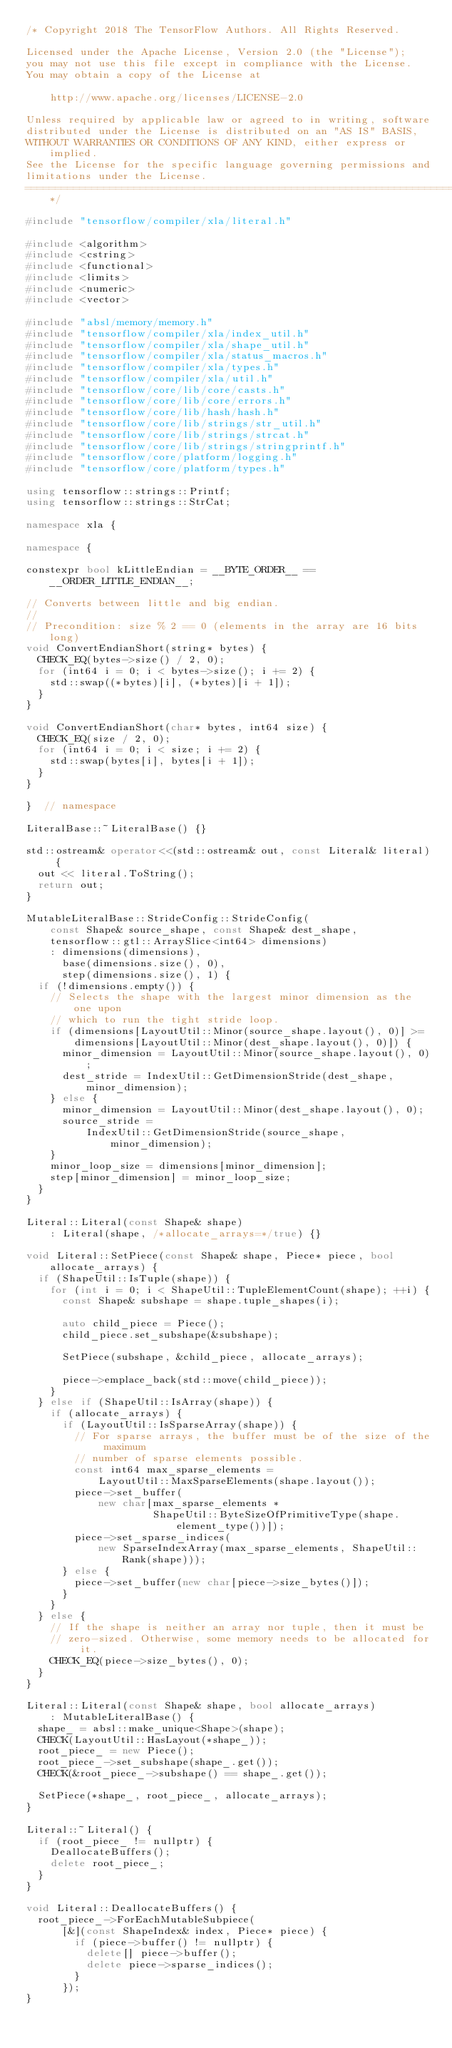<code> <loc_0><loc_0><loc_500><loc_500><_C++_>/* Copyright 2018 The TensorFlow Authors. All Rights Reserved.

Licensed under the Apache License, Version 2.0 (the "License");
you may not use this file except in compliance with the License.
You may obtain a copy of the License at

    http://www.apache.org/licenses/LICENSE-2.0

Unless required by applicable law or agreed to in writing, software
distributed under the License is distributed on an "AS IS" BASIS,
WITHOUT WARRANTIES OR CONDITIONS OF ANY KIND, either express or implied.
See the License for the specific language governing permissions and
limitations under the License.
==============================================================================*/

#include "tensorflow/compiler/xla/literal.h"

#include <algorithm>
#include <cstring>
#include <functional>
#include <limits>
#include <numeric>
#include <vector>

#include "absl/memory/memory.h"
#include "tensorflow/compiler/xla/index_util.h"
#include "tensorflow/compiler/xla/shape_util.h"
#include "tensorflow/compiler/xla/status_macros.h"
#include "tensorflow/compiler/xla/types.h"
#include "tensorflow/compiler/xla/util.h"
#include "tensorflow/core/lib/core/casts.h"
#include "tensorflow/core/lib/core/errors.h"
#include "tensorflow/core/lib/hash/hash.h"
#include "tensorflow/core/lib/strings/str_util.h"
#include "tensorflow/core/lib/strings/strcat.h"
#include "tensorflow/core/lib/strings/stringprintf.h"
#include "tensorflow/core/platform/logging.h"
#include "tensorflow/core/platform/types.h"

using tensorflow::strings::Printf;
using tensorflow::strings::StrCat;

namespace xla {

namespace {

constexpr bool kLittleEndian = __BYTE_ORDER__ == __ORDER_LITTLE_ENDIAN__;

// Converts between little and big endian.
//
// Precondition: size % 2 == 0 (elements in the array are 16 bits long)
void ConvertEndianShort(string* bytes) {
  CHECK_EQ(bytes->size() / 2, 0);
  for (int64 i = 0; i < bytes->size(); i += 2) {
    std::swap((*bytes)[i], (*bytes)[i + 1]);
  }
}

void ConvertEndianShort(char* bytes, int64 size) {
  CHECK_EQ(size / 2, 0);
  for (int64 i = 0; i < size; i += 2) {
    std::swap(bytes[i], bytes[i + 1]);
  }
}

}  // namespace

LiteralBase::~LiteralBase() {}

std::ostream& operator<<(std::ostream& out, const Literal& literal) {
  out << literal.ToString();
  return out;
}

MutableLiteralBase::StrideConfig::StrideConfig(
    const Shape& source_shape, const Shape& dest_shape,
    tensorflow::gtl::ArraySlice<int64> dimensions)
    : dimensions(dimensions),
      base(dimensions.size(), 0),
      step(dimensions.size(), 1) {
  if (!dimensions.empty()) {
    // Selects the shape with the largest minor dimension as the one upon
    // which to run the tight stride loop.
    if (dimensions[LayoutUtil::Minor(source_shape.layout(), 0)] >=
        dimensions[LayoutUtil::Minor(dest_shape.layout(), 0)]) {
      minor_dimension = LayoutUtil::Minor(source_shape.layout(), 0);
      dest_stride = IndexUtil::GetDimensionStride(dest_shape, minor_dimension);
    } else {
      minor_dimension = LayoutUtil::Minor(dest_shape.layout(), 0);
      source_stride =
          IndexUtil::GetDimensionStride(source_shape, minor_dimension);
    }
    minor_loop_size = dimensions[minor_dimension];
    step[minor_dimension] = minor_loop_size;
  }
}

Literal::Literal(const Shape& shape)
    : Literal(shape, /*allocate_arrays=*/true) {}

void Literal::SetPiece(const Shape& shape, Piece* piece, bool allocate_arrays) {
  if (ShapeUtil::IsTuple(shape)) {
    for (int i = 0; i < ShapeUtil::TupleElementCount(shape); ++i) {
      const Shape& subshape = shape.tuple_shapes(i);

      auto child_piece = Piece();
      child_piece.set_subshape(&subshape);

      SetPiece(subshape, &child_piece, allocate_arrays);

      piece->emplace_back(std::move(child_piece));
    }
  } else if (ShapeUtil::IsArray(shape)) {
    if (allocate_arrays) {
      if (LayoutUtil::IsSparseArray(shape)) {
        // For sparse arrays, the buffer must be of the size of the maximum
        // number of sparse elements possible.
        const int64 max_sparse_elements =
            LayoutUtil::MaxSparseElements(shape.layout());
        piece->set_buffer(
            new char[max_sparse_elements *
                     ShapeUtil::ByteSizeOfPrimitiveType(shape.element_type())]);
        piece->set_sparse_indices(
            new SparseIndexArray(max_sparse_elements, ShapeUtil::Rank(shape)));
      } else {
        piece->set_buffer(new char[piece->size_bytes()]);
      }
    }
  } else {
    // If the shape is neither an array nor tuple, then it must be
    // zero-sized. Otherwise, some memory needs to be allocated for it.
    CHECK_EQ(piece->size_bytes(), 0);
  }
}

Literal::Literal(const Shape& shape, bool allocate_arrays)
    : MutableLiteralBase() {
  shape_ = absl::make_unique<Shape>(shape);
  CHECK(LayoutUtil::HasLayout(*shape_));
  root_piece_ = new Piece();
  root_piece_->set_subshape(shape_.get());
  CHECK(&root_piece_->subshape() == shape_.get());

  SetPiece(*shape_, root_piece_, allocate_arrays);
}

Literal::~Literal() {
  if (root_piece_ != nullptr) {
    DeallocateBuffers();
    delete root_piece_;
  }
}

void Literal::DeallocateBuffers() {
  root_piece_->ForEachMutableSubpiece(
      [&](const ShapeIndex& index, Piece* piece) {
        if (piece->buffer() != nullptr) {
          delete[] piece->buffer();
          delete piece->sparse_indices();
        }
      });
}
</code> 